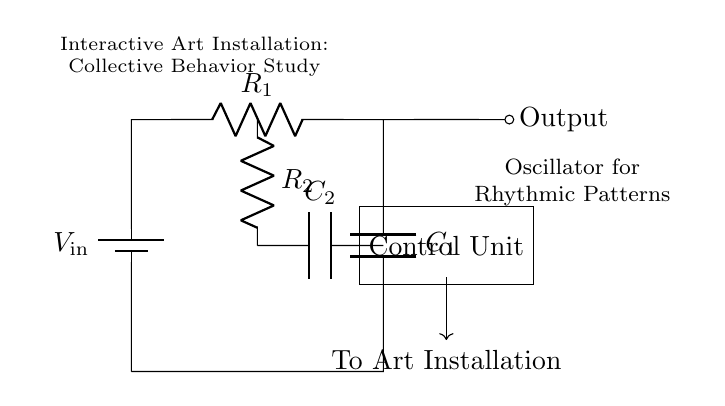What is the type of this circuit? This circuit is an oscillator circuit, typically used for generating rhythmic patterns. The presence of resistors and capacitors indicates that it operates based on time constants derived from these components.
Answer: Oscillator What is the purpose of the control unit? The control unit is indicated to manage the circuit's output, directing the generated rhythmic patterns to the art installation, thus indicating its role in integrating the electronic system with the artwork.
Answer: Control system Which component is responsible for storing energy in this circuit? The capacitor is the component that stores energy, as it can hold charge across its terminals, which is essential for the oscillation process in this specific circuit type.
Answer: Capacitor What is the relationship between R1 and C1? Resistor R1 and capacitor C1 work together to determine the oscillation frequency of the circuit. The time constant is a function of both the resistance and capacitance, dictating how fast the circuit oscillates.
Answer: Frequency determining How many resistors are present in the circuit? There are two resistors depicted in the circuit, which are R1 and R2. They play a crucial role in the behavior of the oscillator as well as the signal output.
Answer: Two What happens when C2 discharges? When capacitor C2 discharges, it releases the stored energy into the circuit, affecting the output signal. This dynamic interaction between C2 and the resistors allows for the generation of the desired rhythmic patterns.
Answer: Output signal changes What is the function of R2 in the circuit? Resistor R2 influences the charging and discharging rate of capacitor C2, thus playing a vital role in controlling the timing characteristics of the oscillation and the overall rhythm generated.
Answer: Timing control 